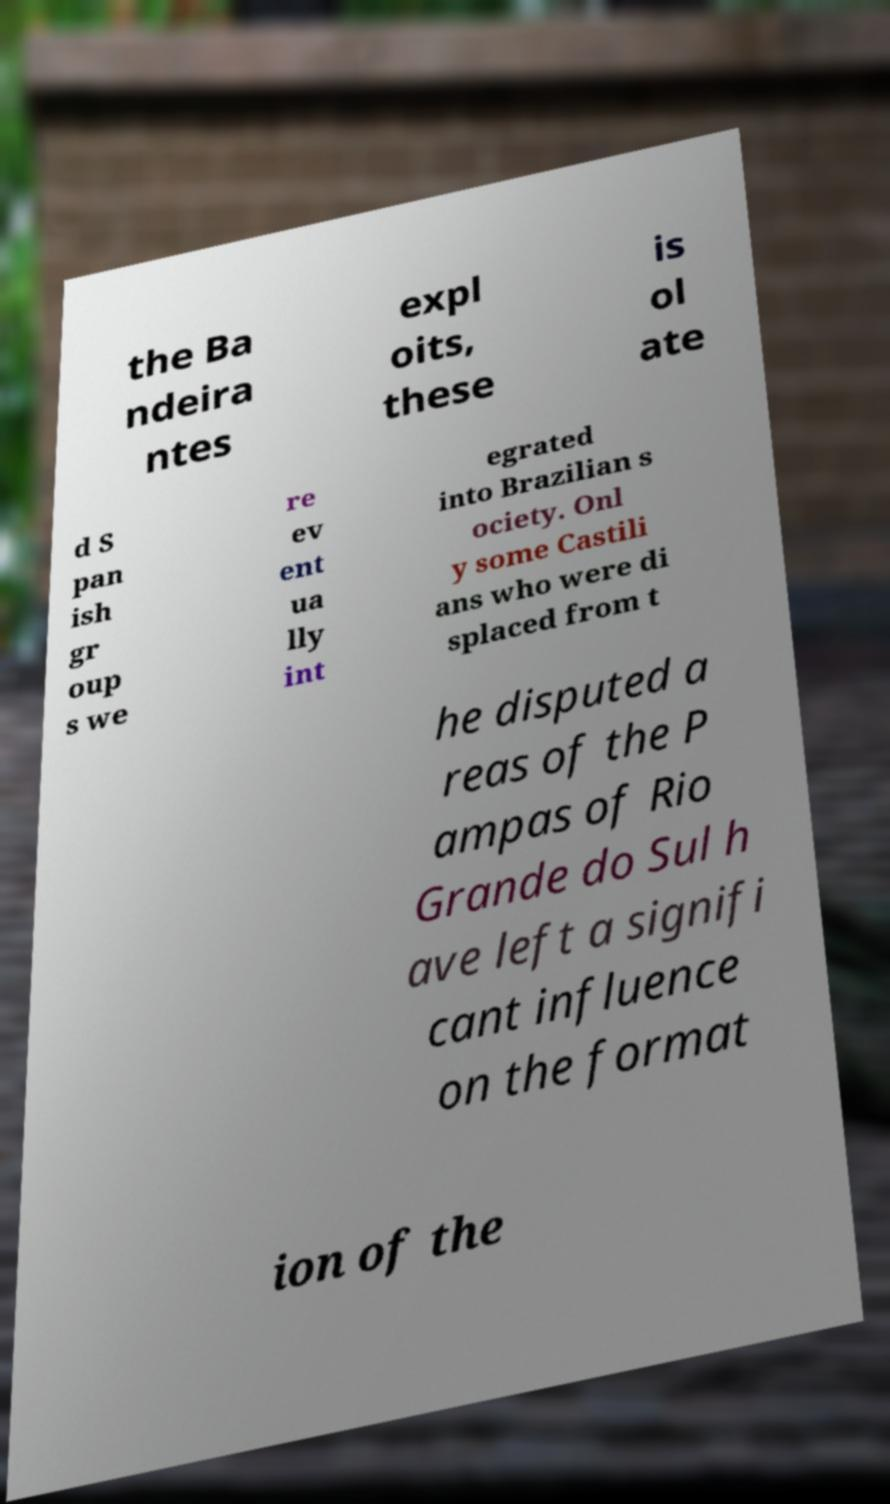For documentation purposes, I need the text within this image transcribed. Could you provide that? the Ba ndeira ntes expl oits, these is ol ate d S pan ish gr oup s we re ev ent ua lly int egrated into Brazilian s ociety. Onl y some Castili ans who were di splaced from t he disputed a reas of the P ampas of Rio Grande do Sul h ave left a signifi cant influence on the format ion of the 